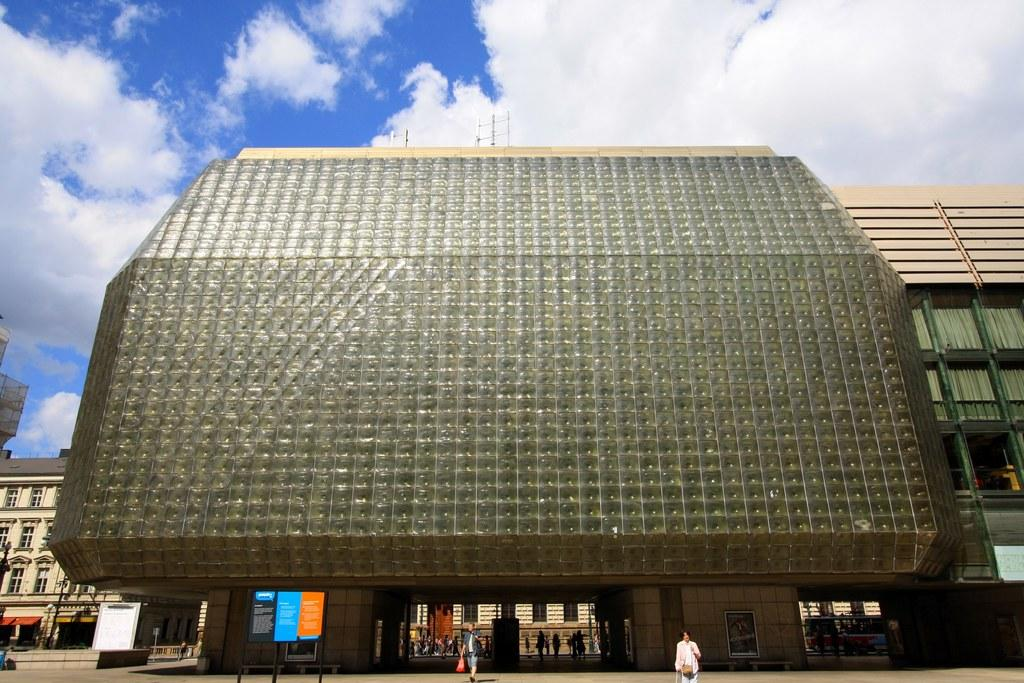What is the weather condition in the image? The sky is cloudy in the image. What type of structures can be seen in the image? There are buildings with windows in the image. Are there any living beings visible in the image? Yes, there are people visible in the image. What else can be seen in the image besides buildings and people? There are hoardings in the image. Are there any laborers or slaves visible in the image? There is no indication of laborers or slaves in the image. The image only shows buildings, people, and hoardings. 